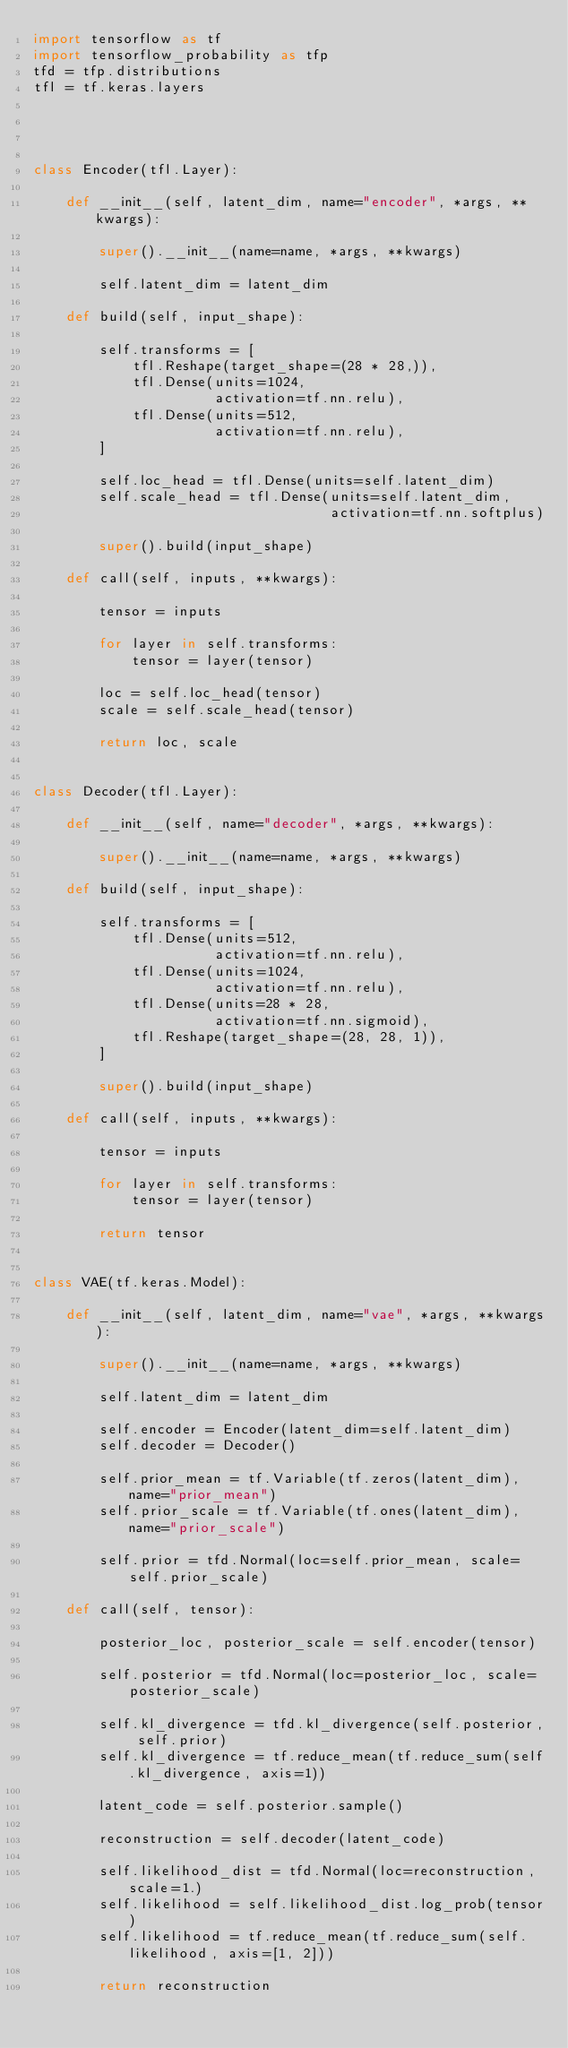<code> <loc_0><loc_0><loc_500><loc_500><_Python_>import tensorflow as tf
import tensorflow_probability as tfp
tfd = tfp.distributions
tfl = tf.keras.layers




class Encoder(tfl.Layer):

    def __init__(self, latent_dim, name="encoder", *args, **kwargs):

        super().__init__(name=name, *args, **kwargs)

        self.latent_dim = latent_dim

    def build(self, input_shape):

        self.transforms = [
            tfl.Reshape(target_shape=(28 * 28,)),
            tfl.Dense(units=1024,
                      activation=tf.nn.relu),
            tfl.Dense(units=512,
                      activation=tf.nn.relu),
        ]

        self.loc_head = tfl.Dense(units=self.latent_dim)
        self.scale_head = tfl.Dense(units=self.latent_dim,
                                    activation=tf.nn.softplus)

        super().build(input_shape)

    def call(self, inputs, **kwargs):

        tensor = inputs

        for layer in self.transforms:
            tensor = layer(tensor)

        loc = self.loc_head(tensor)
        scale = self.scale_head(tensor)

        return loc, scale


class Decoder(tfl.Layer):

    def __init__(self, name="decoder", *args, **kwargs):

        super().__init__(name=name, *args, **kwargs)

    def build(self, input_shape):

        self.transforms = [
            tfl.Dense(units=512,
                      activation=tf.nn.relu),
            tfl.Dense(units=1024,
                      activation=tf.nn.relu),
            tfl.Dense(units=28 * 28,
                      activation=tf.nn.sigmoid),
            tfl.Reshape(target_shape=(28, 28, 1)),
        ]

        super().build(input_shape)

    def call(self, inputs, **kwargs):

        tensor = inputs

        for layer in self.transforms:
            tensor = layer(tensor)

        return tensor


class VAE(tf.keras.Model):

    def __init__(self, latent_dim, name="vae", *args, **kwargs):

        super().__init__(name=name, *args, **kwargs)

        self.latent_dim = latent_dim

        self.encoder = Encoder(latent_dim=self.latent_dim)
        self.decoder = Decoder()

        self.prior_mean = tf.Variable(tf.zeros(latent_dim), name="prior_mean")
        self.prior_scale = tf.Variable(tf.ones(latent_dim), name="prior_scale")

        self.prior = tfd.Normal(loc=self.prior_mean, scale=self.prior_scale)

    def call(self, tensor):

        posterior_loc, posterior_scale = self.encoder(tensor)

        self.posterior = tfd.Normal(loc=posterior_loc, scale=posterior_scale)

        self.kl_divergence = tfd.kl_divergence(self.posterior, self.prior)
        self.kl_divergence = tf.reduce_mean(tf.reduce_sum(self.kl_divergence, axis=1))

        latent_code = self.posterior.sample()

        reconstruction = self.decoder(latent_code)

        self.likelihood_dist = tfd.Normal(loc=reconstruction, scale=1.)
        self.likelihood = self.likelihood_dist.log_prob(tensor)
        self.likelihood = tf.reduce_mean(tf.reduce_sum(self.likelihood, axis=[1, 2]))

        return reconstruction</code> 